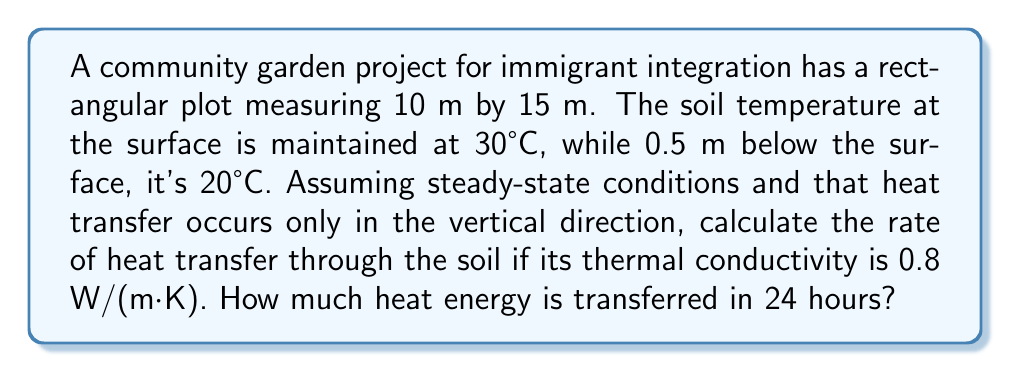Give your solution to this math problem. Let's approach this problem step-by-step using Fourier's law of heat conduction:

1) The heat transfer rate is given by:
   $$Q = -kA\frac{dT}{dx}$$
   where:
   $Q$ = heat transfer rate (W)
   $k$ = thermal conductivity (W/(m·K))
   $A$ = area (m²)
   $\frac{dT}{dx}$ = temperature gradient (K/m)

2) Calculate the area:
   $$A = 10 \text{ m} \times 15 \text{ m} = 150 \text{ m}^2$$

3) Calculate the temperature gradient:
   $$\frac{dT}{dx} = \frac{T_2 - T_1}{x_2 - x_1} = \frac{20°C - 30°C}{0.5 \text{ m} - 0 \text{ m}} = -20 \text{ K/m}$$

4) Now, let's substitute these values into Fourier's law:
   $$Q = -0.8 \frac{\text{W}}{\text{m}\cdot\text{K}} \times 150 \text{ m}^2 \times (-20 \frac{\text{K}}{\text{m}}) = 2400 \text{ W}$$

5) To find the heat energy transferred in 24 hours, we multiply the heat transfer rate by time:
   $$E = Q \times t = 2400 \text{ W} \times (24 \times 3600) \text{ s} = 207,360,000 \text{ J} = 207.36 \text{ MJ}$$
Answer: 2400 W; 207.36 MJ 